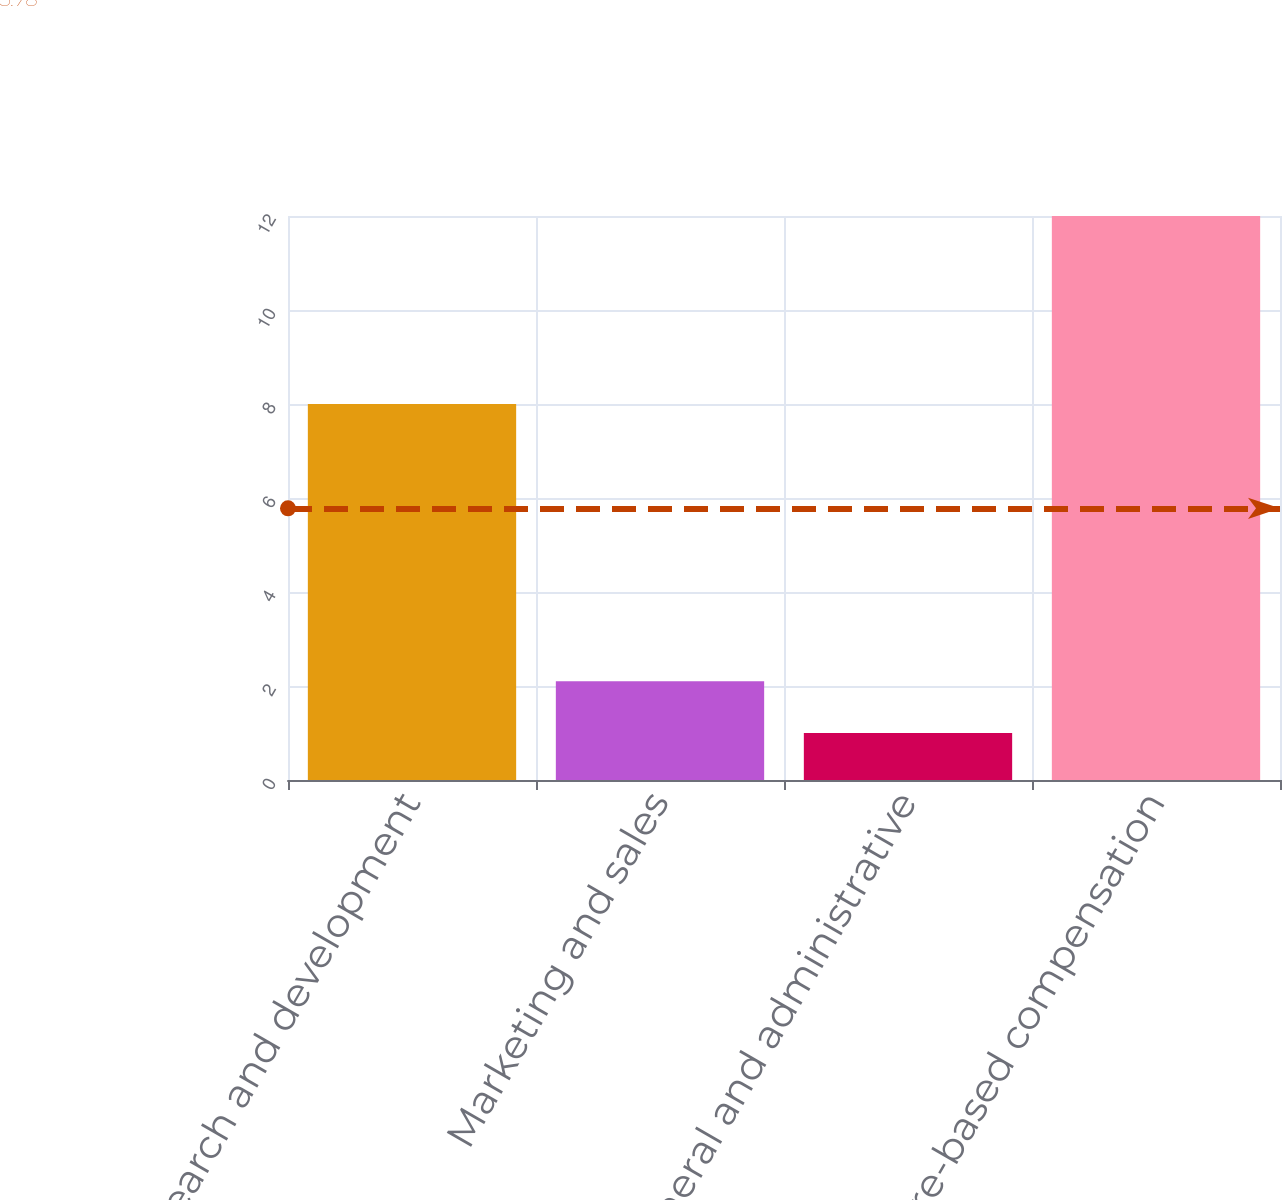Convert chart. <chart><loc_0><loc_0><loc_500><loc_500><bar_chart><fcel>Research and development<fcel>Marketing and sales<fcel>General and administrative<fcel>Total share-based compensation<nl><fcel>8<fcel>2.1<fcel>1<fcel>12<nl></chart> 